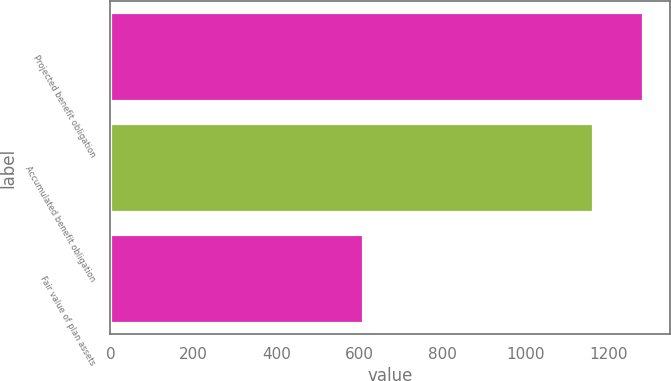Convert chart to OTSL. <chart><loc_0><loc_0><loc_500><loc_500><bar_chart><fcel>Projected benefit obligation<fcel>Accumulated benefit obligation<fcel>Fair value of plan assets<nl><fcel>1284<fcel>1163<fcel>610<nl></chart> 